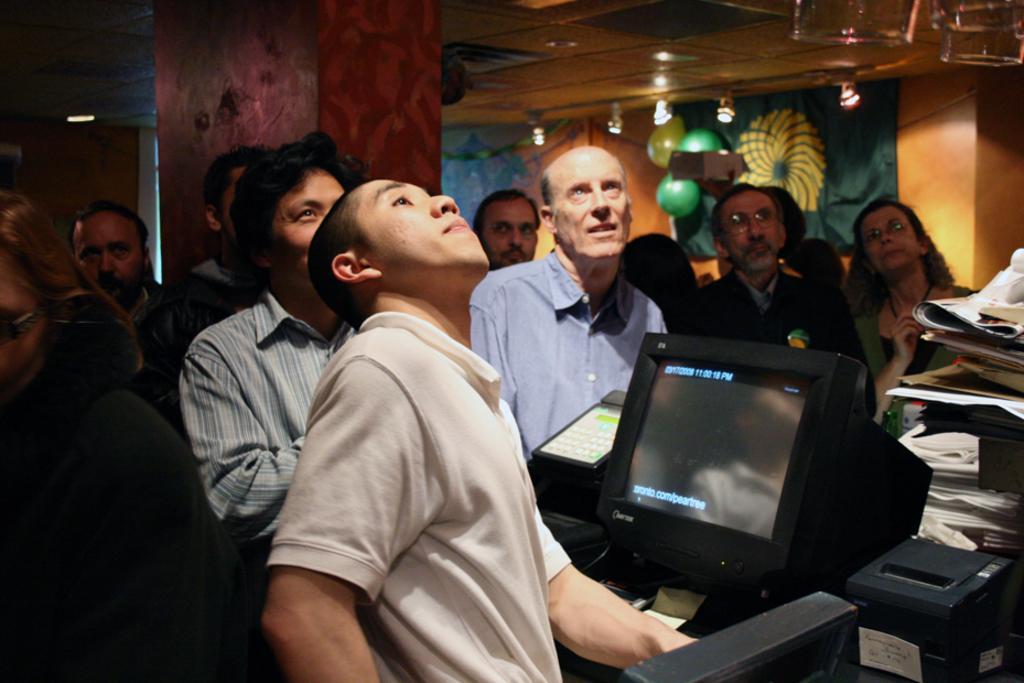Can you describe this image briefly? This image consists of a monitor in black color. And there are many people in this image. At the top, there is a roof. In the middle, there is a pillar. 